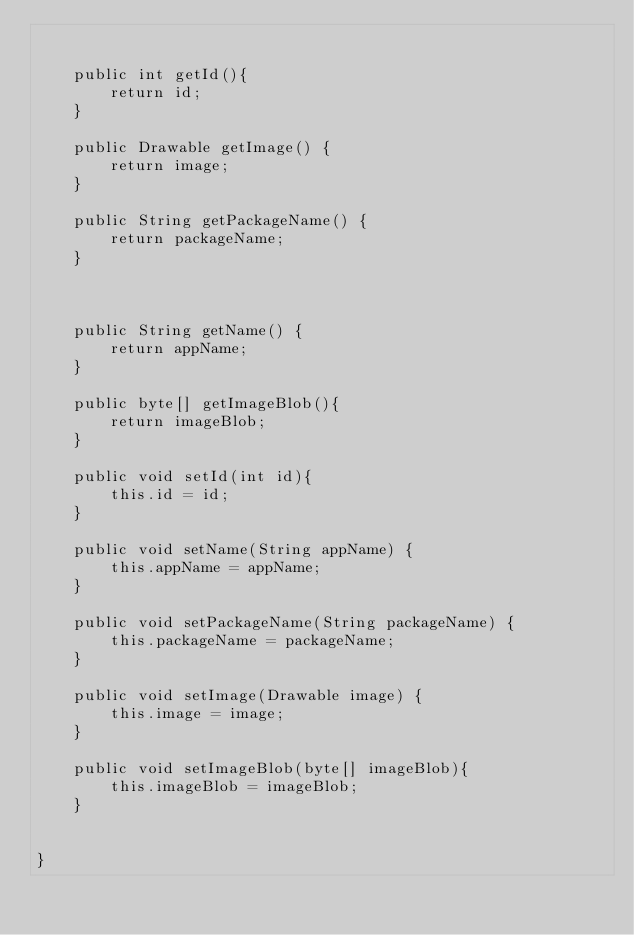Convert code to text. <code><loc_0><loc_0><loc_500><loc_500><_Java_>

    public int getId(){
        return id;
    }

    public Drawable getImage() {
        return image;
    }

    public String getPackageName() {
        return packageName;
    }



    public String getName() {
        return appName;
    }

    public byte[] getImageBlob(){
        return imageBlob;
    }

    public void setId(int id){
        this.id = id;
    }

    public void setName(String appName) {
        this.appName = appName;
    }

    public void setPackageName(String packageName) {
        this.packageName = packageName;
    }

    public void setImage(Drawable image) {
        this.image = image;
    }

    public void setImageBlob(byte[] imageBlob){
        this.imageBlob = imageBlob;
    }


}
</code> 